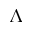Convert formula to latex. <formula><loc_0><loc_0><loc_500><loc_500>\Lambda</formula> 